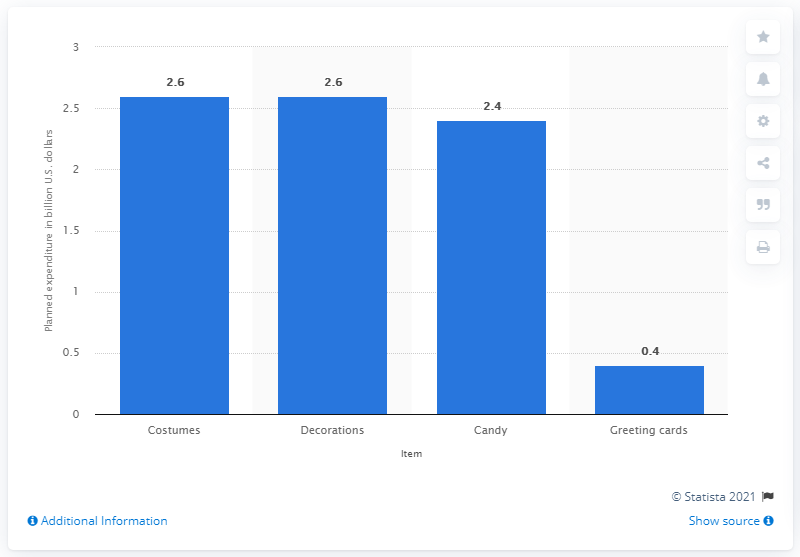Indicate a few pertinent items in this graphic. In 2020, consumers planned to spend an estimated 2.4 dollars on candy for the Halloween season. 